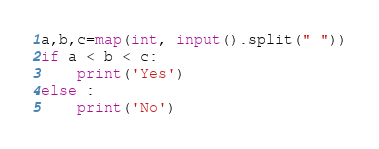Convert code to text. <code><loc_0><loc_0><loc_500><loc_500><_Python_>a,b,c=map(int, input().split(" "))
if a < b < c:
	print('Yes')
else :
	print('No')</code> 